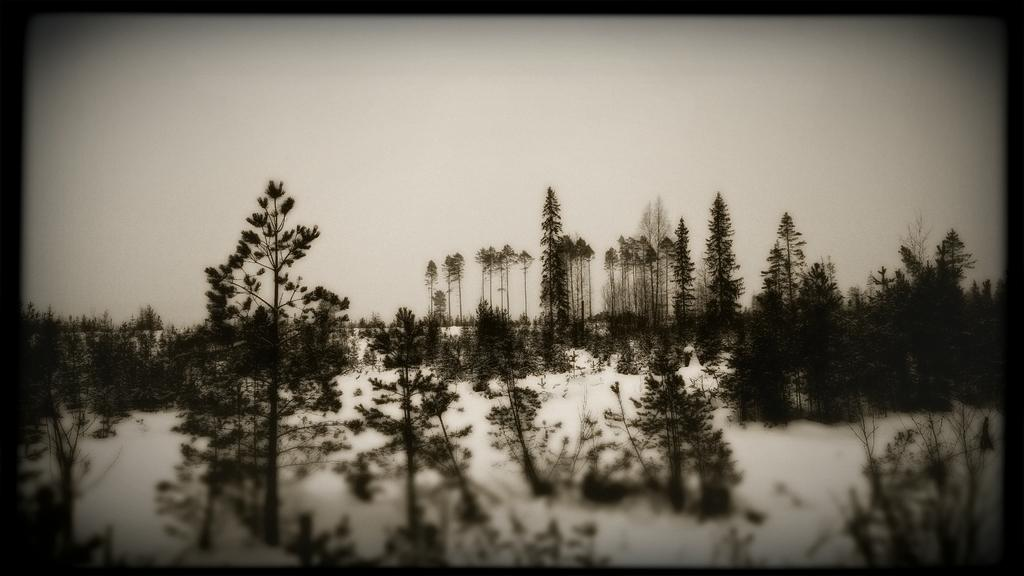What is the color scheme of the image? The image is black and white. What type of vegetation can be seen in the image? There are trees in the image. What is covering the ground in the image? There is snow in the image. What is visible in the background of the image? The sky is visible in the image. What time of day is depicted in the image? The image does not provide any information about the time of day. How many rings are visible on the trees in the image? There are no rings visible on the trees in the image, as it is a black and white image and rings are not visible in this format. 